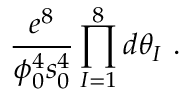Convert formula to latex. <formula><loc_0><loc_0><loc_500><loc_500>\frac { e ^ { 8 } } { \phi _ { 0 } ^ { 4 } s _ { 0 } ^ { 4 } } \prod _ { I = 1 } ^ { 8 } d \theta _ { I } \ .</formula> 